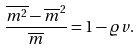Convert formula to latex. <formula><loc_0><loc_0><loc_500><loc_500>\frac { \overline { m ^ { 2 } } - { \overline { m } } ^ { 2 } } { \overline { m } } = 1 - \varrho v .</formula> 